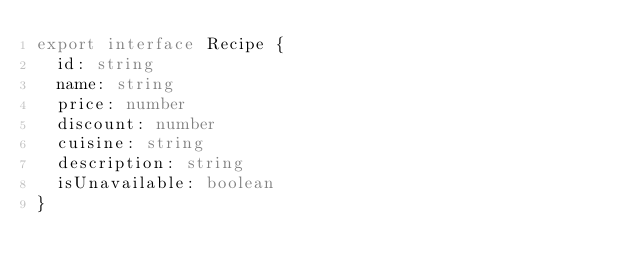Convert code to text. <code><loc_0><loc_0><loc_500><loc_500><_TypeScript_>export interface Recipe {
  id: string
  name: string
  price: number
  discount: number
  cuisine: string
  description: string
  isUnavailable: boolean
}
</code> 